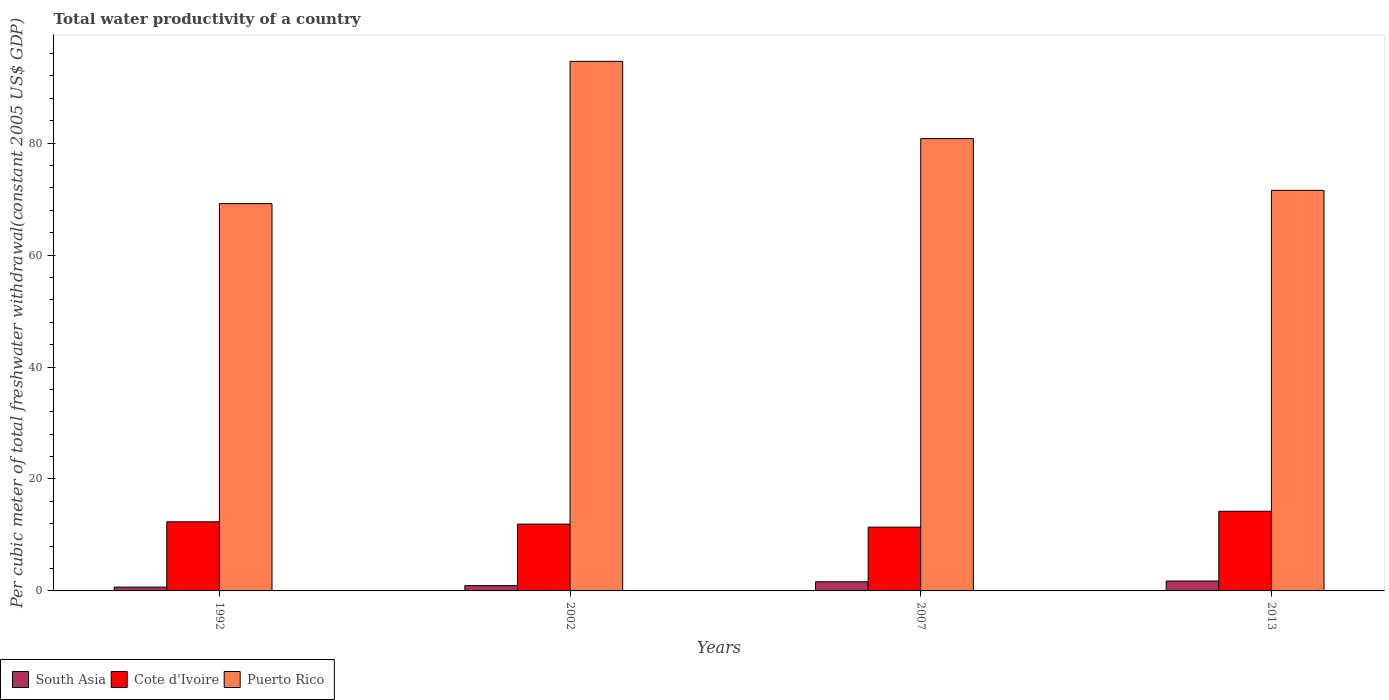How many bars are there on the 4th tick from the left?
Make the answer very short. 3. How many bars are there on the 2nd tick from the right?
Keep it short and to the point. 3. What is the total water productivity in Puerto Rico in 1992?
Provide a short and direct response. 69.19. Across all years, what is the maximum total water productivity in Puerto Rico?
Keep it short and to the point. 94.61. Across all years, what is the minimum total water productivity in Puerto Rico?
Your answer should be very brief. 69.19. In which year was the total water productivity in South Asia maximum?
Make the answer very short. 2013. What is the total total water productivity in South Asia in the graph?
Provide a succinct answer. 5.03. What is the difference between the total water productivity in Puerto Rico in 2007 and that in 2013?
Keep it short and to the point. 9.25. What is the difference between the total water productivity in Cote d'Ivoire in 2007 and the total water productivity in South Asia in 2013?
Make the answer very short. 9.62. What is the average total water productivity in Puerto Rico per year?
Your answer should be compact. 79.04. In the year 2013, what is the difference between the total water productivity in Puerto Rico and total water productivity in Cote d'Ivoire?
Keep it short and to the point. 57.33. What is the ratio of the total water productivity in South Asia in 1992 to that in 2013?
Give a very brief answer. 0.38. Is the difference between the total water productivity in Puerto Rico in 1992 and 2013 greater than the difference between the total water productivity in Cote d'Ivoire in 1992 and 2013?
Provide a short and direct response. No. What is the difference between the highest and the second highest total water productivity in Puerto Rico?
Provide a short and direct response. 13.8. What is the difference between the highest and the lowest total water productivity in Puerto Rico?
Keep it short and to the point. 25.42. Is the sum of the total water productivity in Puerto Rico in 1992 and 2007 greater than the maximum total water productivity in South Asia across all years?
Offer a terse response. Yes. What does the 2nd bar from the left in 2013 represents?
Your answer should be very brief. Cote d'Ivoire. What does the 1st bar from the right in 2007 represents?
Offer a very short reply. Puerto Rico. Is it the case that in every year, the sum of the total water productivity in Puerto Rico and total water productivity in South Asia is greater than the total water productivity in Cote d'Ivoire?
Keep it short and to the point. Yes. Are all the bars in the graph horizontal?
Ensure brevity in your answer.  No. How many years are there in the graph?
Ensure brevity in your answer.  4. What is the difference between two consecutive major ticks on the Y-axis?
Offer a terse response. 20. Where does the legend appear in the graph?
Your answer should be compact. Bottom left. How many legend labels are there?
Your response must be concise. 3. What is the title of the graph?
Your answer should be compact. Total water productivity of a country. Does "Malaysia" appear as one of the legend labels in the graph?
Keep it short and to the point. No. What is the label or title of the X-axis?
Make the answer very short. Years. What is the label or title of the Y-axis?
Make the answer very short. Per cubic meter of total freshwater withdrawal(constant 2005 US$ GDP). What is the Per cubic meter of total freshwater withdrawal(constant 2005 US$ GDP) in South Asia in 1992?
Offer a very short reply. 0.68. What is the Per cubic meter of total freshwater withdrawal(constant 2005 US$ GDP) in Cote d'Ivoire in 1992?
Ensure brevity in your answer.  12.35. What is the Per cubic meter of total freshwater withdrawal(constant 2005 US$ GDP) in Puerto Rico in 1992?
Ensure brevity in your answer.  69.19. What is the Per cubic meter of total freshwater withdrawal(constant 2005 US$ GDP) in South Asia in 2002?
Keep it short and to the point. 0.94. What is the Per cubic meter of total freshwater withdrawal(constant 2005 US$ GDP) of Cote d'Ivoire in 2002?
Keep it short and to the point. 11.94. What is the Per cubic meter of total freshwater withdrawal(constant 2005 US$ GDP) of Puerto Rico in 2002?
Keep it short and to the point. 94.61. What is the Per cubic meter of total freshwater withdrawal(constant 2005 US$ GDP) of South Asia in 2007?
Provide a short and direct response. 1.64. What is the Per cubic meter of total freshwater withdrawal(constant 2005 US$ GDP) of Cote d'Ivoire in 2007?
Make the answer very short. 11.39. What is the Per cubic meter of total freshwater withdrawal(constant 2005 US$ GDP) in Puerto Rico in 2007?
Keep it short and to the point. 80.81. What is the Per cubic meter of total freshwater withdrawal(constant 2005 US$ GDP) in South Asia in 2013?
Your answer should be very brief. 1.77. What is the Per cubic meter of total freshwater withdrawal(constant 2005 US$ GDP) in Cote d'Ivoire in 2013?
Give a very brief answer. 14.23. What is the Per cubic meter of total freshwater withdrawal(constant 2005 US$ GDP) of Puerto Rico in 2013?
Offer a terse response. 71.56. Across all years, what is the maximum Per cubic meter of total freshwater withdrawal(constant 2005 US$ GDP) in South Asia?
Provide a short and direct response. 1.77. Across all years, what is the maximum Per cubic meter of total freshwater withdrawal(constant 2005 US$ GDP) of Cote d'Ivoire?
Make the answer very short. 14.23. Across all years, what is the maximum Per cubic meter of total freshwater withdrawal(constant 2005 US$ GDP) of Puerto Rico?
Offer a very short reply. 94.61. Across all years, what is the minimum Per cubic meter of total freshwater withdrawal(constant 2005 US$ GDP) in South Asia?
Offer a terse response. 0.68. Across all years, what is the minimum Per cubic meter of total freshwater withdrawal(constant 2005 US$ GDP) of Cote d'Ivoire?
Your answer should be compact. 11.39. Across all years, what is the minimum Per cubic meter of total freshwater withdrawal(constant 2005 US$ GDP) in Puerto Rico?
Your answer should be very brief. 69.19. What is the total Per cubic meter of total freshwater withdrawal(constant 2005 US$ GDP) of South Asia in the graph?
Provide a short and direct response. 5.03. What is the total Per cubic meter of total freshwater withdrawal(constant 2005 US$ GDP) in Cote d'Ivoire in the graph?
Ensure brevity in your answer.  49.91. What is the total Per cubic meter of total freshwater withdrawal(constant 2005 US$ GDP) in Puerto Rico in the graph?
Provide a short and direct response. 316.16. What is the difference between the Per cubic meter of total freshwater withdrawal(constant 2005 US$ GDP) of South Asia in 1992 and that in 2002?
Your answer should be compact. -0.26. What is the difference between the Per cubic meter of total freshwater withdrawal(constant 2005 US$ GDP) in Cote d'Ivoire in 1992 and that in 2002?
Give a very brief answer. 0.41. What is the difference between the Per cubic meter of total freshwater withdrawal(constant 2005 US$ GDP) in Puerto Rico in 1992 and that in 2002?
Make the answer very short. -25.42. What is the difference between the Per cubic meter of total freshwater withdrawal(constant 2005 US$ GDP) of South Asia in 1992 and that in 2007?
Your answer should be compact. -0.96. What is the difference between the Per cubic meter of total freshwater withdrawal(constant 2005 US$ GDP) of Cote d'Ivoire in 1992 and that in 2007?
Offer a very short reply. 0.95. What is the difference between the Per cubic meter of total freshwater withdrawal(constant 2005 US$ GDP) of Puerto Rico in 1992 and that in 2007?
Provide a short and direct response. -11.62. What is the difference between the Per cubic meter of total freshwater withdrawal(constant 2005 US$ GDP) in South Asia in 1992 and that in 2013?
Keep it short and to the point. -1.09. What is the difference between the Per cubic meter of total freshwater withdrawal(constant 2005 US$ GDP) in Cote d'Ivoire in 1992 and that in 2013?
Your response must be concise. -1.88. What is the difference between the Per cubic meter of total freshwater withdrawal(constant 2005 US$ GDP) in Puerto Rico in 1992 and that in 2013?
Offer a very short reply. -2.37. What is the difference between the Per cubic meter of total freshwater withdrawal(constant 2005 US$ GDP) of South Asia in 2002 and that in 2007?
Ensure brevity in your answer.  -0.69. What is the difference between the Per cubic meter of total freshwater withdrawal(constant 2005 US$ GDP) in Cote d'Ivoire in 2002 and that in 2007?
Give a very brief answer. 0.54. What is the difference between the Per cubic meter of total freshwater withdrawal(constant 2005 US$ GDP) in Puerto Rico in 2002 and that in 2007?
Keep it short and to the point. 13.8. What is the difference between the Per cubic meter of total freshwater withdrawal(constant 2005 US$ GDP) of South Asia in 2002 and that in 2013?
Give a very brief answer. -0.83. What is the difference between the Per cubic meter of total freshwater withdrawal(constant 2005 US$ GDP) in Cote d'Ivoire in 2002 and that in 2013?
Your answer should be very brief. -2.29. What is the difference between the Per cubic meter of total freshwater withdrawal(constant 2005 US$ GDP) of Puerto Rico in 2002 and that in 2013?
Your answer should be compact. 23.05. What is the difference between the Per cubic meter of total freshwater withdrawal(constant 2005 US$ GDP) of South Asia in 2007 and that in 2013?
Your answer should be very brief. -0.13. What is the difference between the Per cubic meter of total freshwater withdrawal(constant 2005 US$ GDP) of Cote d'Ivoire in 2007 and that in 2013?
Keep it short and to the point. -2.83. What is the difference between the Per cubic meter of total freshwater withdrawal(constant 2005 US$ GDP) of Puerto Rico in 2007 and that in 2013?
Make the answer very short. 9.25. What is the difference between the Per cubic meter of total freshwater withdrawal(constant 2005 US$ GDP) in South Asia in 1992 and the Per cubic meter of total freshwater withdrawal(constant 2005 US$ GDP) in Cote d'Ivoire in 2002?
Offer a very short reply. -11.26. What is the difference between the Per cubic meter of total freshwater withdrawal(constant 2005 US$ GDP) of South Asia in 1992 and the Per cubic meter of total freshwater withdrawal(constant 2005 US$ GDP) of Puerto Rico in 2002?
Give a very brief answer. -93.93. What is the difference between the Per cubic meter of total freshwater withdrawal(constant 2005 US$ GDP) of Cote d'Ivoire in 1992 and the Per cubic meter of total freshwater withdrawal(constant 2005 US$ GDP) of Puerto Rico in 2002?
Your response must be concise. -82.26. What is the difference between the Per cubic meter of total freshwater withdrawal(constant 2005 US$ GDP) of South Asia in 1992 and the Per cubic meter of total freshwater withdrawal(constant 2005 US$ GDP) of Cote d'Ivoire in 2007?
Your answer should be very brief. -10.71. What is the difference between the Per cubic meter of total freshwater withdrawal(constant 2005 US$ GDP) of South Asia in 1992 and the Per cubic meter of total freshwater withdrawal(constant 2005 US$ GDP) of Puerto Rico in 2007?
Your answer should be very brief. -80.13. What is the difference between the Per cubic meter of total freshwater withdrawal(constant 2005 US$ GDP) of Cote d'Ivoire in 1992 and the Per cubic meter of total freshwater withdrawal(constant 2005 US$ GDP) of Puerto Rico in 2007?
Give a very brief answer. -68.46. What is the difference between the Per cubic meter of total freshwater withdrawal(constant 2005 US$ GDP) in South Asia in 1992 and the Per cubic meter of total freshwater withdrawal(constant 2005 US$ GDP) in Cote d'Ivoire in 2013?
Your response must be concise. -13.55. What is the difference between the Per cubic meter of total freshwater withdrawal(constant 2005 US$ GDP) in South Asia in 1992 and the Per cubic meter of total freshwater withdrawal(constant 2005 US$ GDP) in Puerto Rico in 2013?
Your response must be concise. -70.88. What is the difference between the Per cubic meter of total freshwater withdrawal(constant 2005 US$ GDP) in Cote d'Ivoire in 1992 and the Per cubic meter of total freshwater withdrawal(constant 2005 US$ GDP) in Puerto Rico in 2013?
Your response must be concise. -59.21. What is the difference between the Per cubic meter of total freshwater withdrawal(constant 2005 US$ GDP) of South Asia in 2002 and the Per cubic meter of total freshwater withdrawal(constant 2005 US$ GDP) of Cote d'Ivoire in 2007?
Offer a terse response. -10.45. What is the difference between the Per cubic meter of total freshwater withdrawal(constant 2005 US$ GDP) of South Asia in 2002 and the Per cubic meter of total freshwater withdrawal(constant 2005 US$ GDP) of Puerto Rico in 2007?
Offer a terse response. -79.86. What is the difference between the Per cubic meter of total freshwater withdrawal(constant 2005 US$ GDP) in Cote d'Ivoire in 2002 and the Per cubic meter of total freshwater withdrawal(constant 2005 US$ GDP) in Puerto Rico in 2007?
Make the answer very short. -68.87. What is the difference between the Per cubic meter of total freshwater withdrawal(constant 2005 US$ GDP) of South Asia in 2002 and the Per cubic meter of total freshwater withdrawal(constant 2005 US$ GDP) of Cote d'Ivoire in 2013?
Provide a succinct answer. -13.29. What is the difference between the Per cubic meter of total freshwater withdrawal(constant 2005 US$ GDP) in South Asia in 2002 and the Per cubic meter of total freshwater withdrawal(constant 2005 US$ GDP) in Puerto Rico in 2013?
Your response must be concise. -70.62. What is the difference between the Per cubic meter of total freshwater withdrawal(constant 2005 US$ GDP) in Cote d'Ivoire in 2002 and the Per cubic meter of total freshwater withdrawal(constant 2005 US$ GDP) in Puerto Rico in 2013?
Make the answer very short. -59.62. What is the difference between the Per cubic meter of total freshwater withdrawal(constant 2005 US$ GDP) in South Asia in 2007 and the Per cubic meter of total freshwater withdrawal(constant 2005 US$ GDP) in Cote d'Ivoire in 2013?
Your response must be concise. -12.59. What is the difference between the Per cubic meter of total freshwater withdrawal(constant 2005 US$ GDP) of South Asia in 2007 and the Per cubic meter of total freshwater withdrawal(constant 2005 US$ GDP) of Puerto Rico in 2013?
Provide a succinct answer. -69.92. What is the difference between the Per cubic meter of total freshwater withdrawal(constant 2005 US$ GDP) in Cote d'Ivoire in 2007 and the Per cubic meter of total freshwater withdrawal(constant 2005 US$ GDP) in Puerto Rico in 2013?
Offer a very short reply. -60.17. What is the average Per cubic meter of total freshwater withdrawal(constant 2005 US$ GDP) of South Asia per year?
Keep it short and to the point. 1.26. What is the average Per cubic meter of total freshwater withdrawal(constant 2005 US$ GDP) of Cote d'Ivoire per year?
Provide a succinct answer. 12.48. What is the average Per cubic meter of total freshwater withdrawal(constant 2005 US$ GDP) in Puerto Rico per year?
Ensure brevity in your answer.  79.04. In the year 1992, what is the difference between the Per cubic meter of total freshwater withdrawal(constant 2005 US$ GDP) of South Asia and Per cubic meter of total freshwater withdrawal(constant 2005 US$ GDP) of Cote d'Ivoire?
Keep it short and to the point. -11.67. In the year 1992, what is the difference between the Per cubic meter of total freshwater withdrawal(constant 2005 US$ GDP) in South Asia and Per cubic meter of total freshwater withdrawal(constant 2005 US$ GDP) in Puerto Rico?
Make the answer very short. -68.51. In the year 1992, what is the difference between the Per cubic meter of total freshwater withdrawal(constant 2005 US$ GDP) in Cote d'Ivoire and Per cubic meter of total freshwater withdrawal(constant 2005 US$ GDP) in Puerto Rico?
Provide a short and direct response. -56.84. In the year 2002, what is the difference between the Per cubic meter of total freshwater withdrawal(constant 2005 US$ GDP) of South Asia and Per cubic meter of total freshwater withdrawal(constant 2005 US$ GDP) of Cote d'Ivoire?
Provide a short and direct response. -10.99. In the year 2002, what is the difference between the Per cubic meter of total freshwater withdrawal(constant 2005 US$ GDP) in South Asia and Per cubic meter of total freshwater withdrawal(constant 2005 US$ GDP) in Puerto Rico?
Offer a very short reply. -93.66. In the year 2002, what is the difference between the Per cubic meter of total freshwater withdrawal(constant 2005 US$ GDP) in Cote d'Ivoire and Per cubic meter of total freshwater withdrawal(constant 2005 US$ GDP) in Puerto Rico?
Your answer should be very brief. -82.67. In the year 2007, what is the difference between the Per cubic meter of total freshwater withdrawal(constant 2005 US$ GDP) in South Asia and Per cubic meter of total freshwater withdrawal(constant 2005 US$ GDP) in Cote d'Ivoire?
Offer a very short reply. -9.76. In the year 2007, what is the difference between the Per cubic meter of total freshwater withdrawal(constant 2005 US$ GDP) of South Asia and Per cubic meter of total freshwater withdrawal(constant 2005 US$ GDP) of Puerto Rico?
Keep it short and to the point. -79.17. In the year 2007, what is the difference between the Per cubic meter of total freshwater withdrawal(constant 2005 US$ GDP) in Cote d'Ivoire and Per cubic meter of total freshwater withdrawal(constant 2005 US$ GDP) in Puerto Rico?
Your response must be concise. -69.41. In the year 2013, what is the difference between the Per cubic meter of total freshwater withdrawal(constant 2005 US$ GDP) of South Asia and Per cubic meter of total freshwater withdrawal(constant 2005 US$ GDP) of Cote d'Ivoire?
Ensure brevity in your answer.  -12.46. In the year 2013, what is the difference between the Per cubic meter of total freshwater withdrawal(constant 2005 US$ GDP) of South Asia and Per cubic meter of total freshwater withdrawal(constant 2005 US$ GDP) of Puerto Rico?
Your answer should be compact. -69.79. In the year 2013, what is the difference between the Per cubic meter of total freshwater withdrawal(constant 2005 US$ GDP) of Cote d'Ivoire and Per cubic meter of total freshwater withdrawal(constant 2005 US$ GDP) of Puerto Rico?
Offer a terse response. -57.33. What is the ratio of the Per cubic meter of total freshwater withdrawal(constant 2005 US$ GDP) in South Asia in 1992 to that in 2002?
Offer a very short reply. 0.72. What is the ratio of the Per cubic meter of total freshwater withdrawal(constant 2005 US$ GDP) in Cote d'Ivoire in 1992 to that in 2002?
Your response must be concise. 1.03. What is the ratio of the Per cubic meter of total freshwater withdrawal(constant 2005 US$ GDP) in Puerto Rico in 1992 to that in 2002?
Your answer should be very brief. 0.73. What is the ratio of the Per cubic meter of total freshwater withdrawal(constant 2005 US$ GDP) in South Asia in 1992 to that in 2007?
Your answer should be compact. 0.42. What is the ratio of the Per cubic meter of total freshwater withdrawal(constant 2005 US$ GDP) in Cote d'Ivoire in 1992 to that in 2007?
Give a very brief answer. 1.08. What is the ratio of the Per cubic meter of total freshwater withdrawal(constant 2005 US$ GDP) in Puerto Rico in 1992 to that in 2007?
Your response must be concise. 0.86. What is the ratio of the Per cubic meter of total freshwater withdrawal(constant 2005 US$ GDP) in South Asia in 1992 to that in 2013?
Your answer should be compact. 0.38. What is the ratio of the Per cubic meter of total freshwater withdrawal(constant 2005 US$ GDP) of Cote d'Ivoire in 1992 to that in 2013?
Your response must be concise. 0.87. What is the ratio of the Per cubic meter of total freshwater withdrawal(constant 2005 US$ GDP) of Puerto Rico in 1992 to that in 2013?
Your answer should be compact. 0.97. What is the ratio of the Per cubic meter of total freshwater withdrawal(constant 2005 US$ GDP) of South Asia in 2002 to that in 2007?
Give a very brief answer. 0.58. What is the ratio of the Per cubic meter of total freshwater withdrawal(constant 2005 US$ GDP) of Cote d'Ivoire in 2002 to that in 2007?
Offer a very short reply. 1.05. What is the ratio of the Per cubic meter of total freshwater withdrawal(constant 2005 US$ GDP) in Puerto Rico in 2002 to that in 2007?
Offer a very short reply. 1.17. What is the ratio of the Per cubic meter of total freshwater withdrawal(constant 2005 US$ GDP) of South Asia in 2002 to that in 2013?
Provide a succinct answer. 0.53. What is the ratio of the Per cubic meter of total freshwater withdrawal(constant 2005 US$ GDP) in Cote d'Ivoire in 2002 to that in 2013?
Provide a short and direct response. 0.84. What is the ratio of the Per cubic meter of total freshwater withdrawal(constant 2005 US$ GDP) in Puerto Rico in 2002 to that in 2013?
Provide a short and direct response. 1.32. What is the ratio of the Per cubic meter of total freshwater withdrawal(constant 2005 US$ GDP) of South Asia in 2007 to that in 2013?
Offer a very short reply. 0.92. What is the ratio of the Per cubic meter of total freshwater withdrawal(constant 2005 US$ GDP) in Cote d'Ivoire in 2007 to that in 2013?
Provide a short and direct response. 0.8. What is the ratio of the Per cubic meter of total freshwater withdrawal(constant 2005 US$ GDP) in Puerto Rico in 2007 to that in 2013?
Give a very brief answer. 1.13. What is the difference between the highest and the second highest Per cubic meter of total freshwater withdrawal(constant 2005 US$ GDP) of South Asia?
Keep it short and to the point. 0.13. What is the difference between the highest and the second highest Per cubic meter of total freshwater withdrawal(constant 2005 US$ GDP) of Cote d'Ivoire?
Your answer should be very brief. 1.88. What is the difference between the highest and the second highest Per cubic meter of total freshwater withdrawal(constant 2005 US$ GDP) of Puerto Rico?
Provide a short and direct response. 13.8. What is the difference between the highest and the lowest Per cubic meter of total freshwater withdrawal(constant 2005 US$ GDP) of South Asia?
Keep it short and to the point. 1.09. What is the difference between the highest and the lowest Per cubic meter of total freshwater withdrawal(constant 2005 US$ GDP) in Cote d'Ivoire?
Offer a terse response. 2.83. What is the difference between the highest and the lowest Per cubic meter of total freshwater withdrawal(constant 2005 US$ GDP) of Puerto Rico?
Provide a succinct answer. 25.42. 